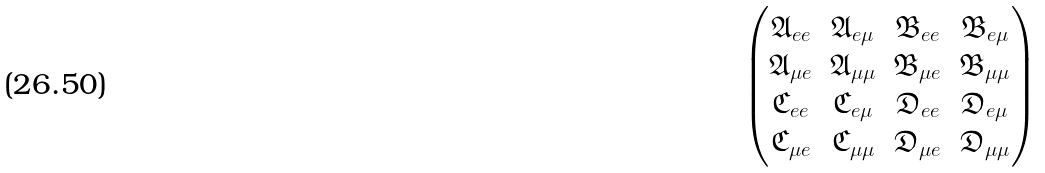Convert formula to latex. <formula><loc_0><loc_0><loc_500><loc_500>\begin{pmatrix} \mathfrak { A } _ { e e } & \mathfrak { A } _ { e \mu } & \mathfrak { B } _ { e e } & \mathfrak { B } _ { e \mu } \\ \mathfrak { A } _ { \mu e } & \mathfrak { A } _ { \mu \mu } & \mathfrak { B } _ { \mu e } & \mathfrak { B } _ { \mu \mu } \\ \mathfrak { C } _ { e e } & \mathfrak { C } _ { e \mu } & \mathfrak { D } _ { e e } & \mathfrak { D } _ { e \mu } \\ \mathfrak { C } _ { \mu e } & \mathfrak { C } _ { \mu \mu } & \mathfrak { D } _ { \mu e } & \mathfrak { D } _ { \mu \mu } \\ \end{pmatrix}</formula> 